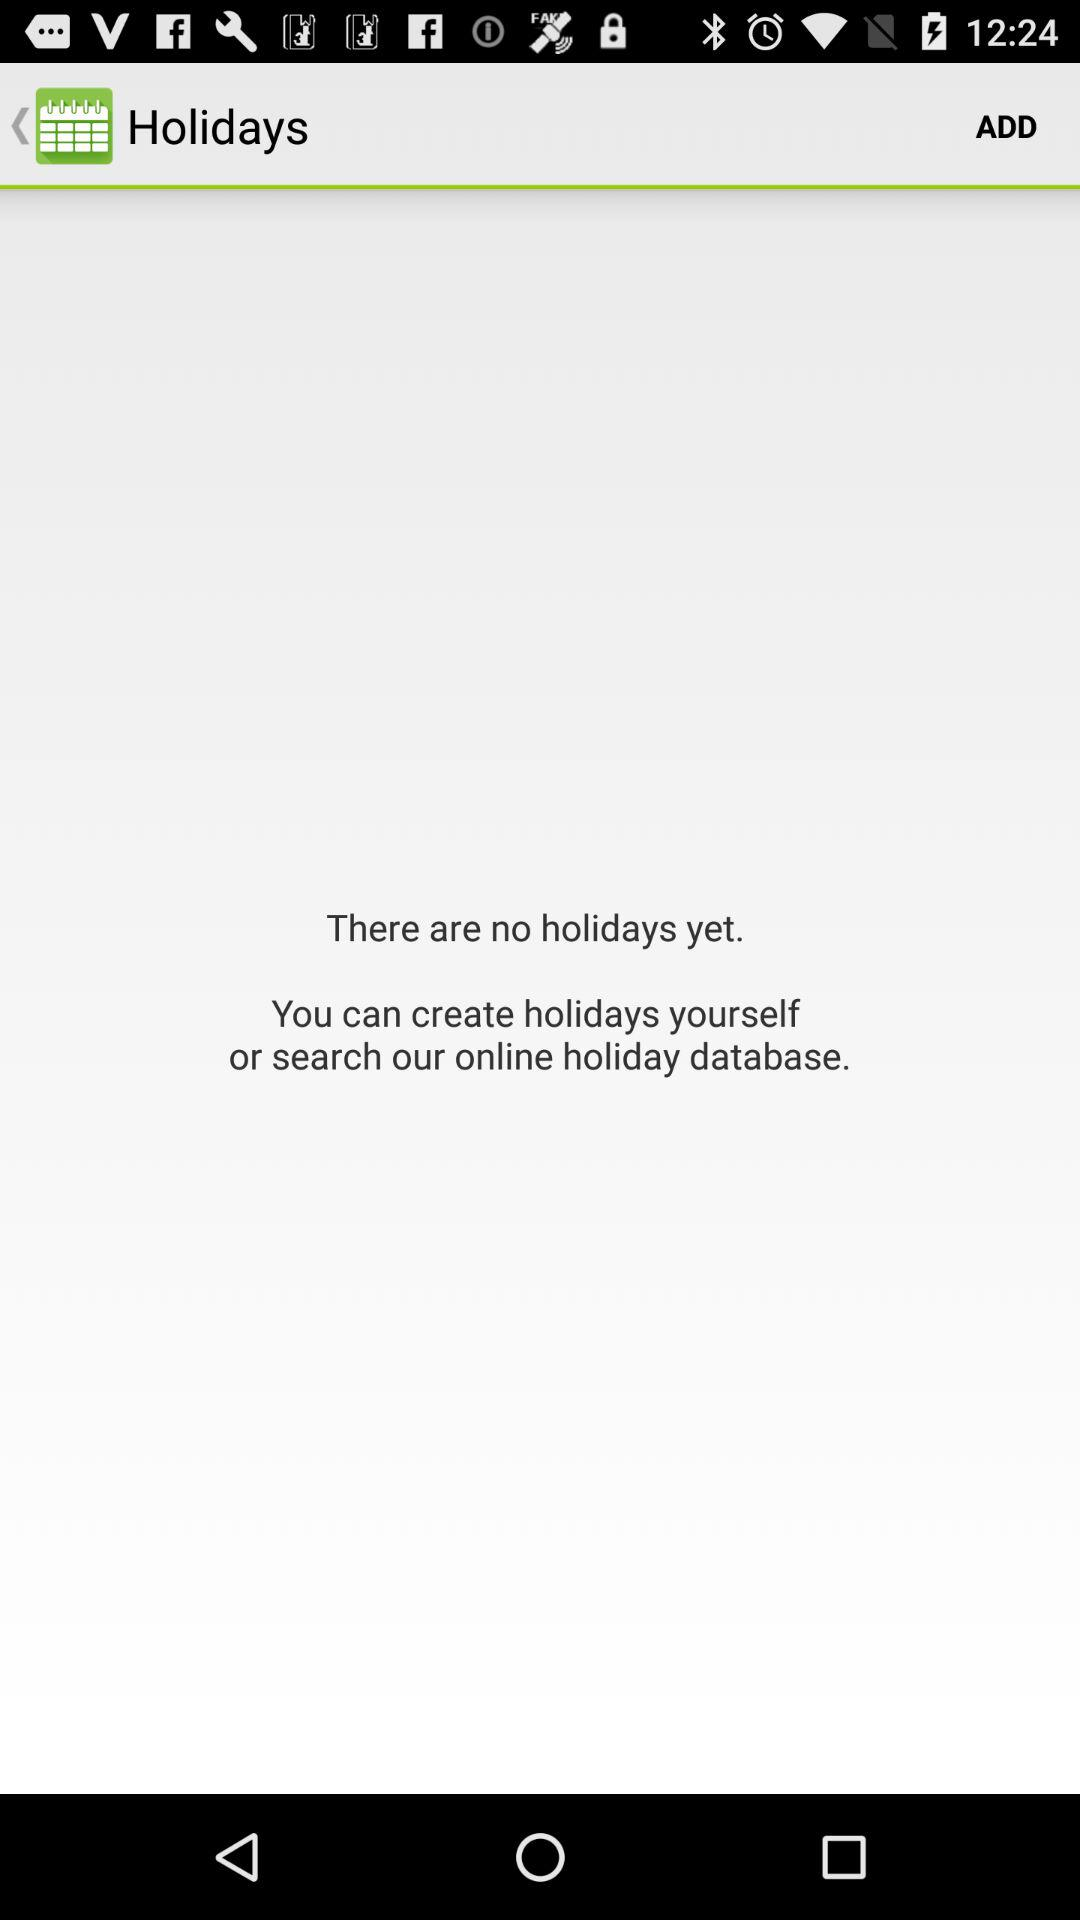Are there any holidays? There are no holidays. 